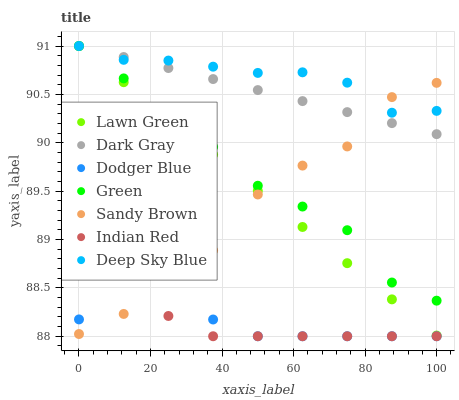Does Indian Red have the minimum area under the curve?
Answer yes or no. Yes. Does Deep Sky Blue have the maximum area under the curve?
Answer yes or no. Yes. Does Dark Gray have the minimum area under the curve?
Answer yes or no. No. Does Dark Gray have the maximum area under the curve?
Answer yes or no. No. Is Dark Gray the smoothest?
Answer yes or no. Yes. Is Sandy Brown the roughest?
Answer yes or no. Yes. Is Deep Sky Blue the smoothest?
Answer yes or no. No. Is Deep Sky Blue the roughest?
Answer yes or no. No. Does Indian Red have the lowest value?
Answer yes or no. Yes. Does Dark Gray have the lowest value?
Answer yes or no. No. Does Green have the highest value?
Answer yes or no. Yes. Does Indian Red have the highest value?
Answer yes or no. No. Is Dodger Blue less than Deep Sky Blue?
Answer yes or no. Yes. Is Deep Sky Blue greater than Dodger Blue?
Answer yes or no. Yes. Does Dodger Blue intersect Sandy Brown?
Answer yes or no. Yes. Is Dodger Blue less than Sandy Brown?
Answer yes or no. No. Is Dodger Blue greater than Sandy Brown?
Answer yes or no. No. Does Dodger Blue intersect Deep Sky Blue?
Answer yes or no. No. 